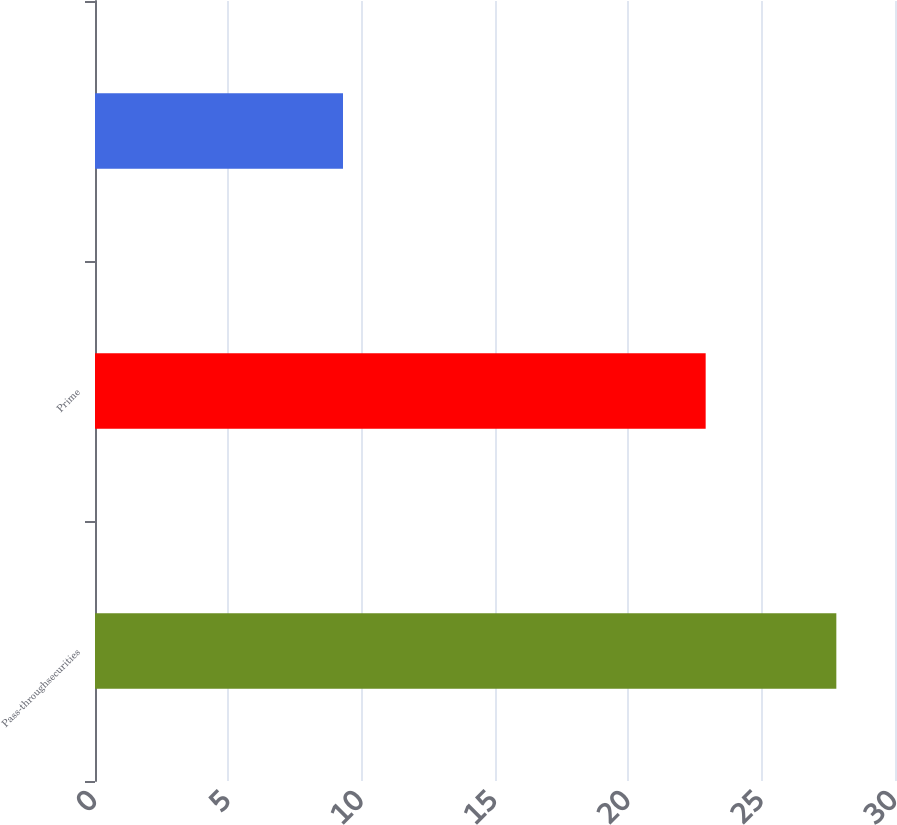Convert chart to OTSL. <chart><loc_0><loc_0><loc_500><loc_500><bar_chart><fcel>Pass-throughsecurities<fcel>Prime<fcel>Unnamed: 2<nl><fcel>27.8<fcel>22.9<fcel>9.3<nl></chart> 